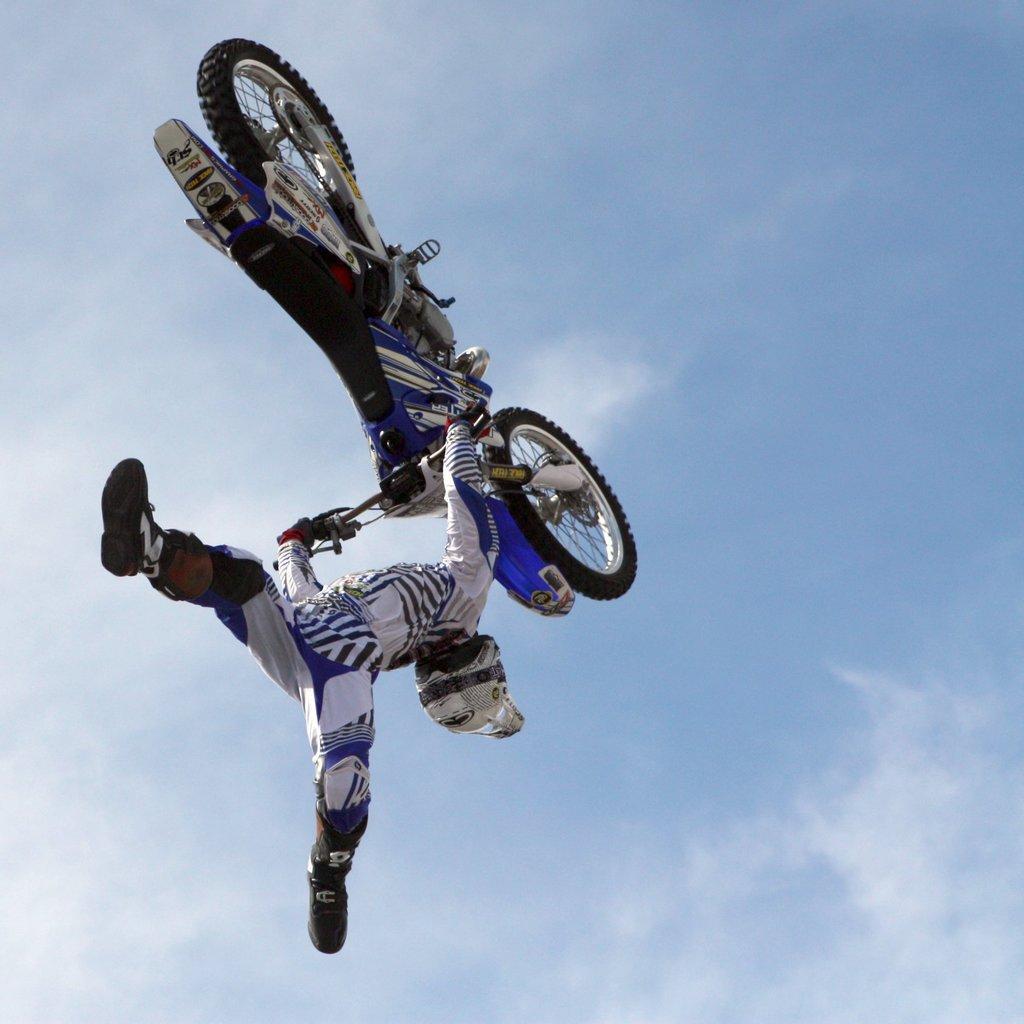How would you summarize this image in a sentence or two? In this image there is a person holding the bike and he is in the air. In the background of the image there is sky. 